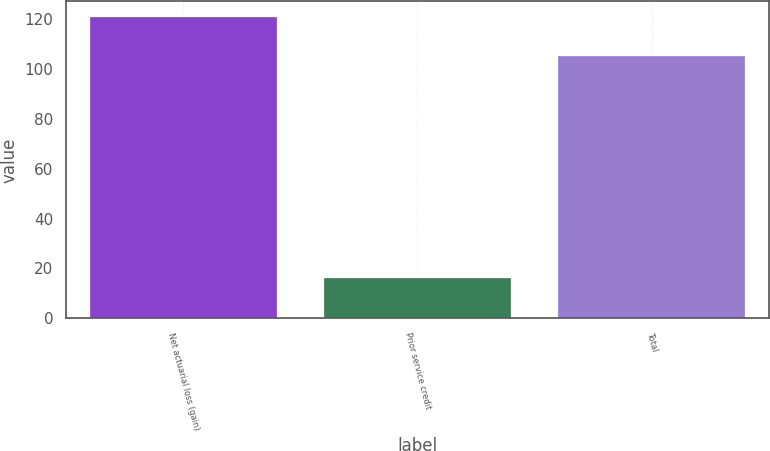Convert chart. <chart><loc_0><loc_0><loc_500><loc_500><bar_chart><fcel>Net actuarial loss (gain)<fcel>Prior service credit<fcel>Total<nl><fcel>121<fcel>16<fcel>105<nl></chart> 